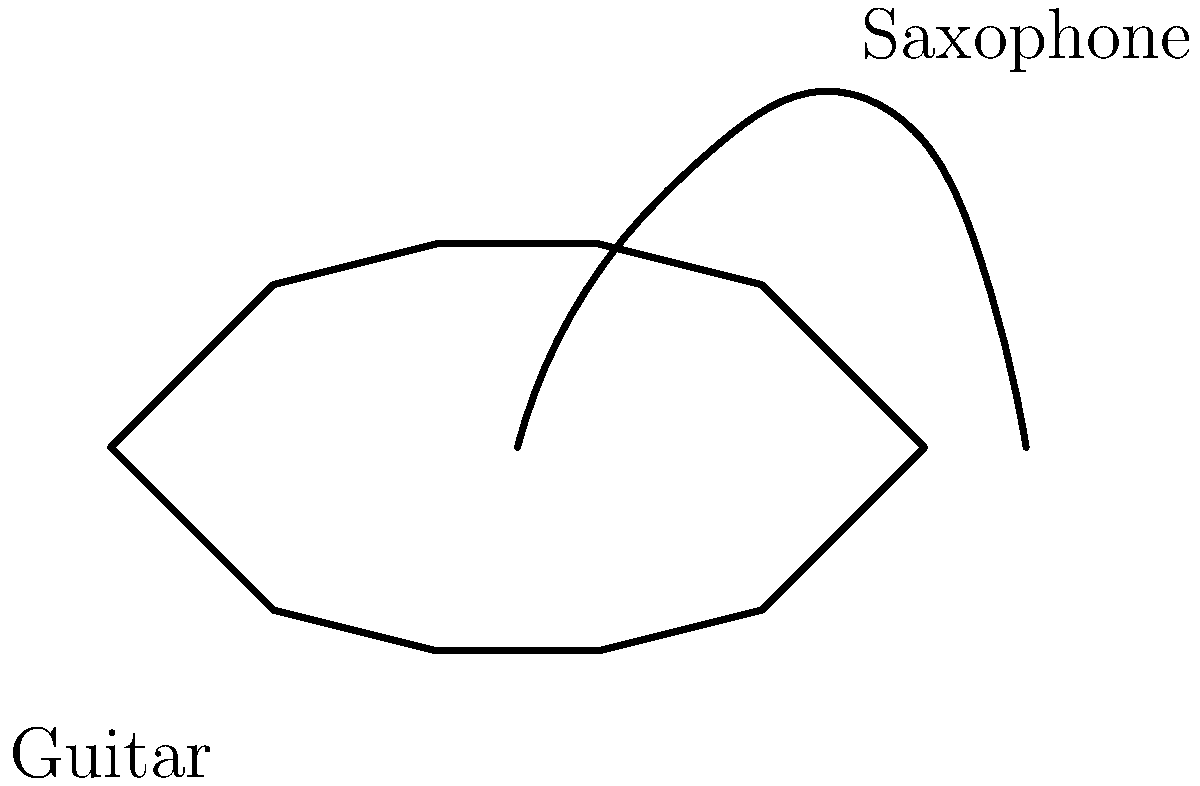Consider the shapes of a guitar and a saxophone as shown in the diagram. The guitar's body can be approximated as an ellipse, while the saxophone's main tube can be modeled as a conical frustum. If the guitar's body has a major axis of 50 cm and a minor axis of 30 cm, and the saxophone's tube has a length of 66 cm with end diameters of 1.5 cm and 6 cm, calculate the ratio of their surface areas. How might this difference in surface area affect their acoustic properties? Let's approach this step-by-step:

1. Guitar (approximated as an ellipse):
   - Surface area of an ellipse: $A_g = \pi ab$
   - Where $a = 25$ cm (half of major axis) and $b = 15$ cm (half of minor axis)
   - $A_g = \pi(25)(15) = 1178.10$ cm²

2. Saxophone (modeled as a conical frustum):
   - Surface area of a conical frustum: $A_s = \pi(r_1 + r_2)\sqrt{h^2 + (r_2 - r_1)^2}$
   - Where $r_1 = 0.75$ cm, $r_2 = 3$ cm, and $h = 66$ cm
   - $A_s = \pi(0.75 + 3)\sqrt{66^2 + (3 - 0.75)^2} = 494.81$ cm²

3. Ratio of surface areas:
   $\frac{A_g}{A_s} = \frac{1178.10}{494.81} \approx 2.38$

4. Acoustic properties:
   - The guitar's larger surface area allows for more vibration and resonance, contributing to its rich, full sound.
   - The saxophone's smaller surface area and conical shape help to produce a more focused, directional sound with higher frequencies.
   - The ratio indicates that the guitar has about 2.38 times more surface area than the saxophone, which partly explains why guitars tend to have a fuller, more resonant sound compared to the brighter, more focused sound of saxophones.
Answer: 2.38:1 (guitar:saxophone); larger surface area of guitar allows for more vibration and resonance, while saxophone's smaller area produces a more focused sound. 